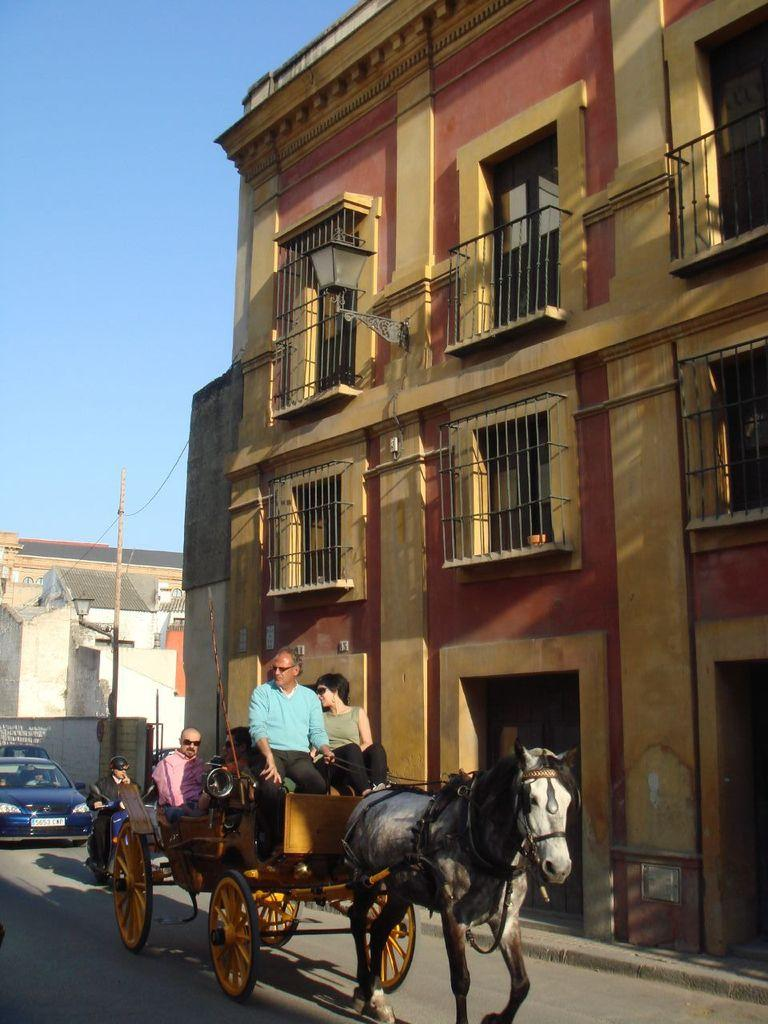What are the people in the image doing? There are persons sitting on a horse car in the image. What can be seen in the background of the image? There are vehicles and buildings in the background of the image. What type of needle is being used to sew the horse car in the image? There is no needle present in the image, and the horse car is not being sewn. 